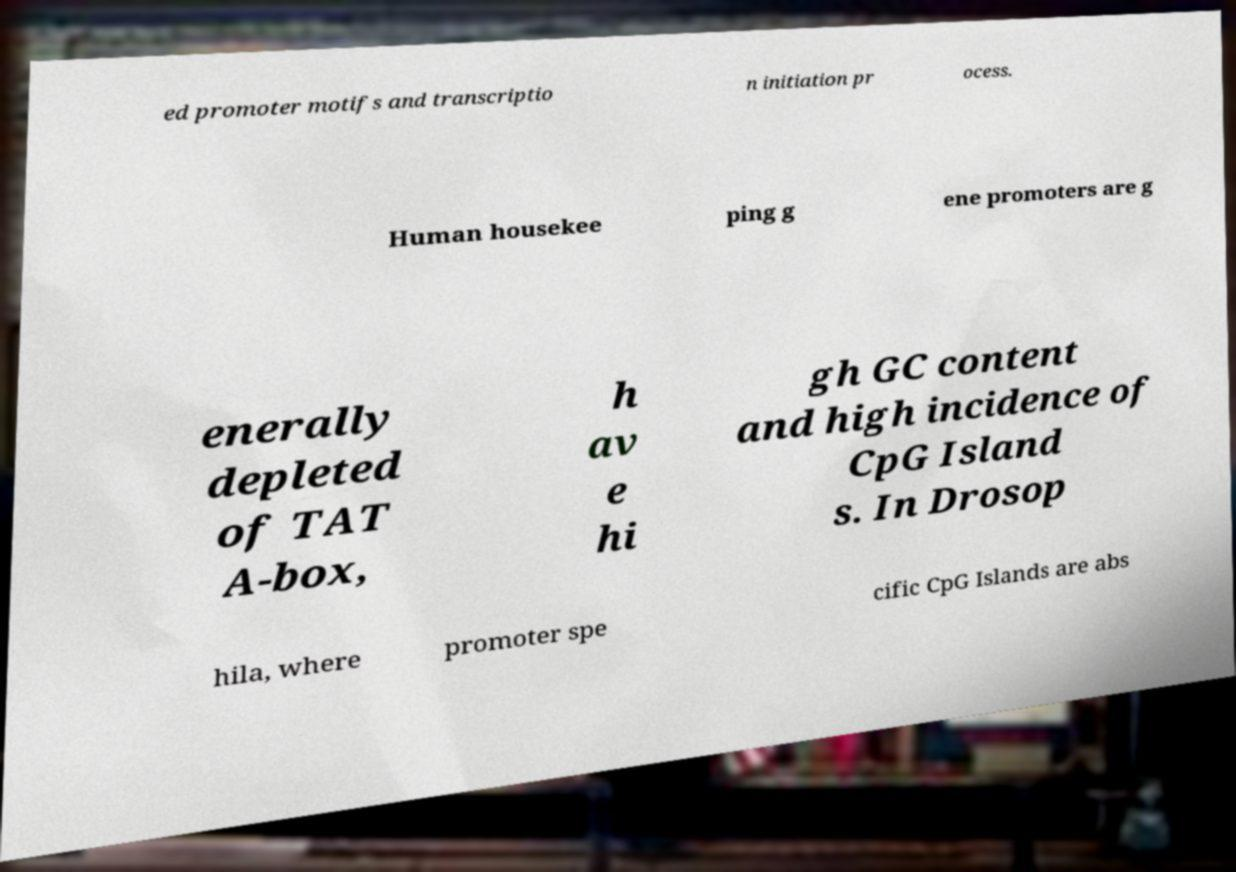Please identify and transcribe the text found in this image. ed promoter motifs and transcriptio n initiation pr ocess. Human housekee ping g ene promoters are g enerally depleted of TAT A-box, h av e hi gh GC content and high incidence of CpG Island s. In Drosop hila, where promoter spe cific CpG Islands are abs 